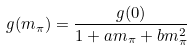Convert formula to latex. <formula><loc_0><loc_0><loc_500><loc_500>g ( m _ { \pi } ) = \frac { g ( 0 ) } { 1 + a m _ { \pi } + b m _ { \pi } ^ { 2 } }</formula> 